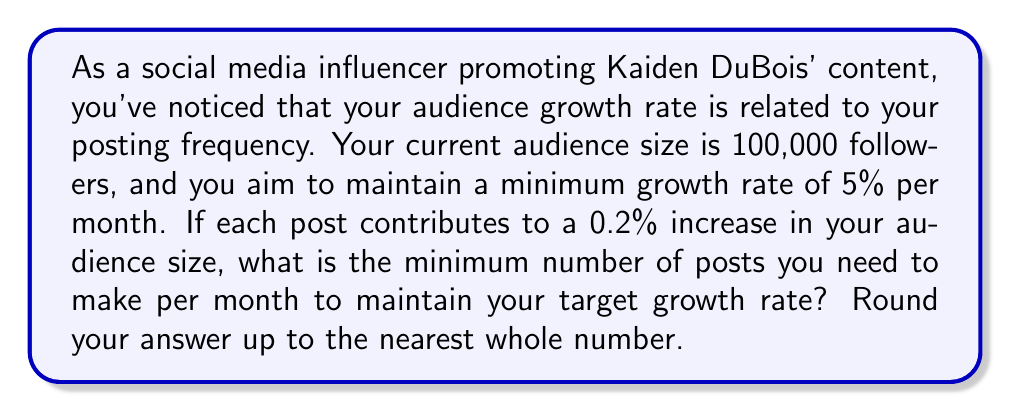Provide a solution to this math problem. Let's approach this step-by-step:

1) First, let's define our variables:
   $x$ = number of posts per month
   $g$ = growth rate per month (5% = 0.05)
   $p$ = growth per post (0.2% = 0.002)

2) We want to find the minimum $x$ that satisfies the inequality:

   $$ px \geq g $$

3) Substituting our known values:

   $$ 0.002x \geq 0.05 $$

4) To solve for $x$, we divide both sides by 0.002:

   $$ x \geq \frac{0.05}{0.002} = 25 $$

5) Since we can't make a fractional number of posts, and we need the minimum number that satisfies the inequality, we round up to the nearest whole number.

Therefore, the minimum number of posts required is 25.
Answer: 25 posts per month 